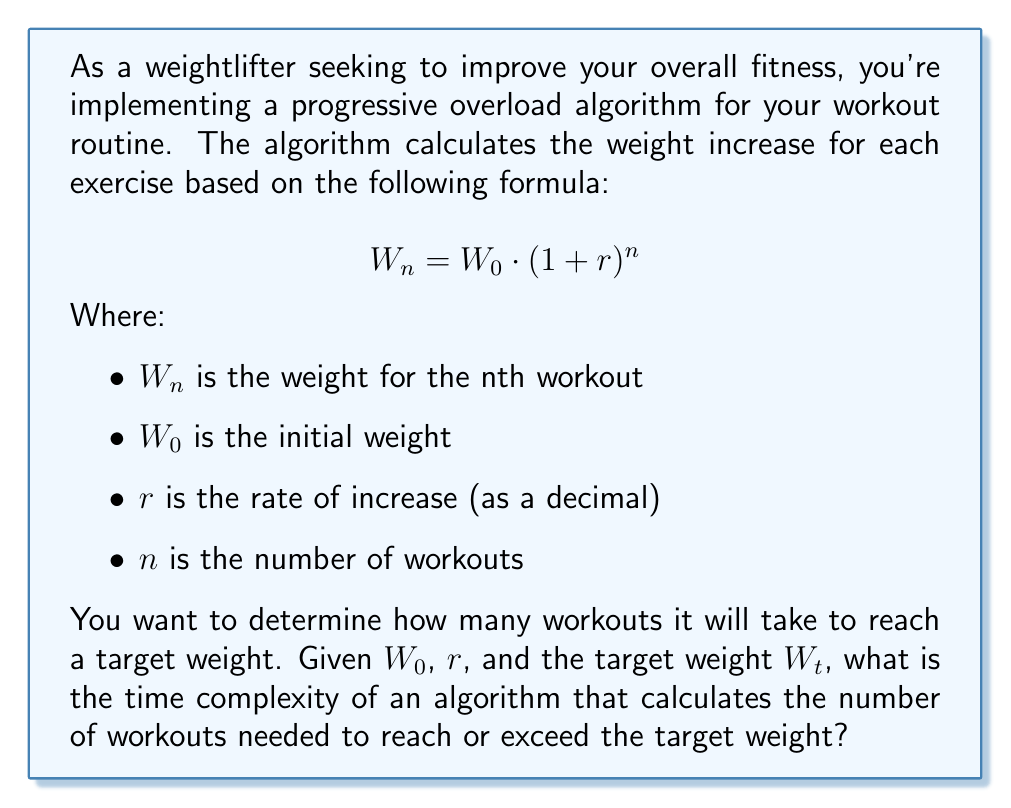Can you solve this math problem? To solve this problem, let's break it down into steps:

1) First, we need to rearrange the given formula to solve for $n$:

   $$W_n = W_0 \cdot (1 + r)^n$$
   $$\frac{W_n}{W_0} = (1 + r)^n$$
   $$\log_{1+r}(\frac{W_n}{W_0}) = n$$

2) Now, we can express $n$ in terms of $W_t$ (target weight):

   $$n = \log_{1+r}(\frac{W_t}{W_0})$$

3) To calculate this logarithm, we can use the change of base formula:

   $$n = \frac{\log(\frac{W_t}{W_0})}{\log(1+r)}$$

4) In terms of algorithm implementation, this calculation involves:
   - One division ($\frac{W_t}{W_0}$)
   - Two logarithm calculations
   - One more division

5) All these operations (division and logarithm) are considered constant time operations in most programming contexts.

6) After calculating $n$, we need to round up to the nearest integer, as we can't have a fractional number of workouts. This is also a constant time operation.

7) Therefore, the entire calculation can be done in constant time, regardless of the input values.

The time complexity of this algorithm is O(1), or constant time complexity.
Answer: O(1) 